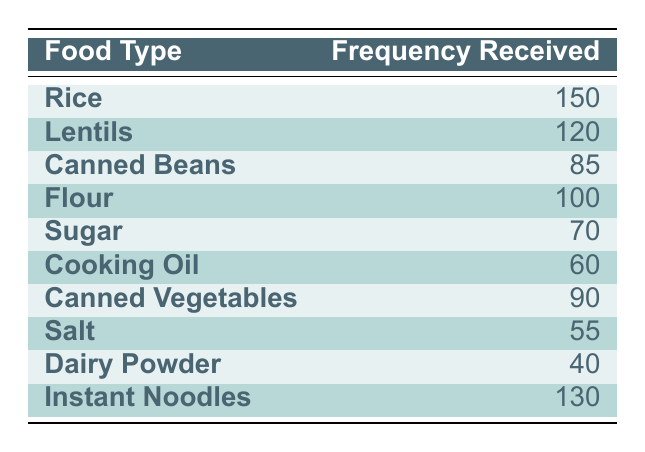What type of food received the highest frequency? The table lists the frequencies of different food types received. By examining the "Frequency Received" column, I see that Rice has a frequency of 150, which is higher than all other food types.
Answer: Rice What is the frequency of Canned Beans received? Looking at the table, Canned Beans has a frequency of 85 listed under "Frequency Received."
Answer: 85 Which food type received the least amount of aid? To find the least amount of aid received, I will check the "Frequency Received" column for the lowest number. Dairy Powder has a frequency of 40, which is less than all others.
Answer: Dairy Powder What is the total frequency received for Instant Noodles and Cooking Oil combined? I will add the frequencies of Instant Noodles (130) and Cooking Oil (60) together. The sum is 130 + 60 = 190.
Answer: 190 Are more lentils received than cooking oil? I compare the frequencies: Lentils received 120, while Cooking Oil received 60. Since 120 is greater than 60, the statement is true.
Answer: Yes What is the average frequency of food types received from the distribution? First, I will sum all the frequencies: 150 + 120 + 85 + 100 + 70 + 60 + 90 + 55 + 40 + 130 = 1,000. Then, since there are 10 food types, I calculate the average by dividing 1,000 by 10, resulting in an average of 100.
Answer: 100 Is it true that more than half of the food types received a frequency of over 100? I check the frequencies: Rice (150), Lentils (120), and Instant Noodles (130) are above 100, making a count of 3 out of 10 food types, which is not more than half.
Answer: No What is the difference in frequency received between Rice and Sugar? I will subtract the frequency of Sugar (70) from the frequency of Rice (150). The difference is 150 - 70 = 80.
Answer: 80 How many food types received a frequency of 90 or higher? I check the "Frequency Received" column and find there are 5 food types: Rice (150), Lentils (120), Instant Noodles (130), Flour (100), and Canned Vegetables (90). So, the total is 5 food types.
Answer: 5 